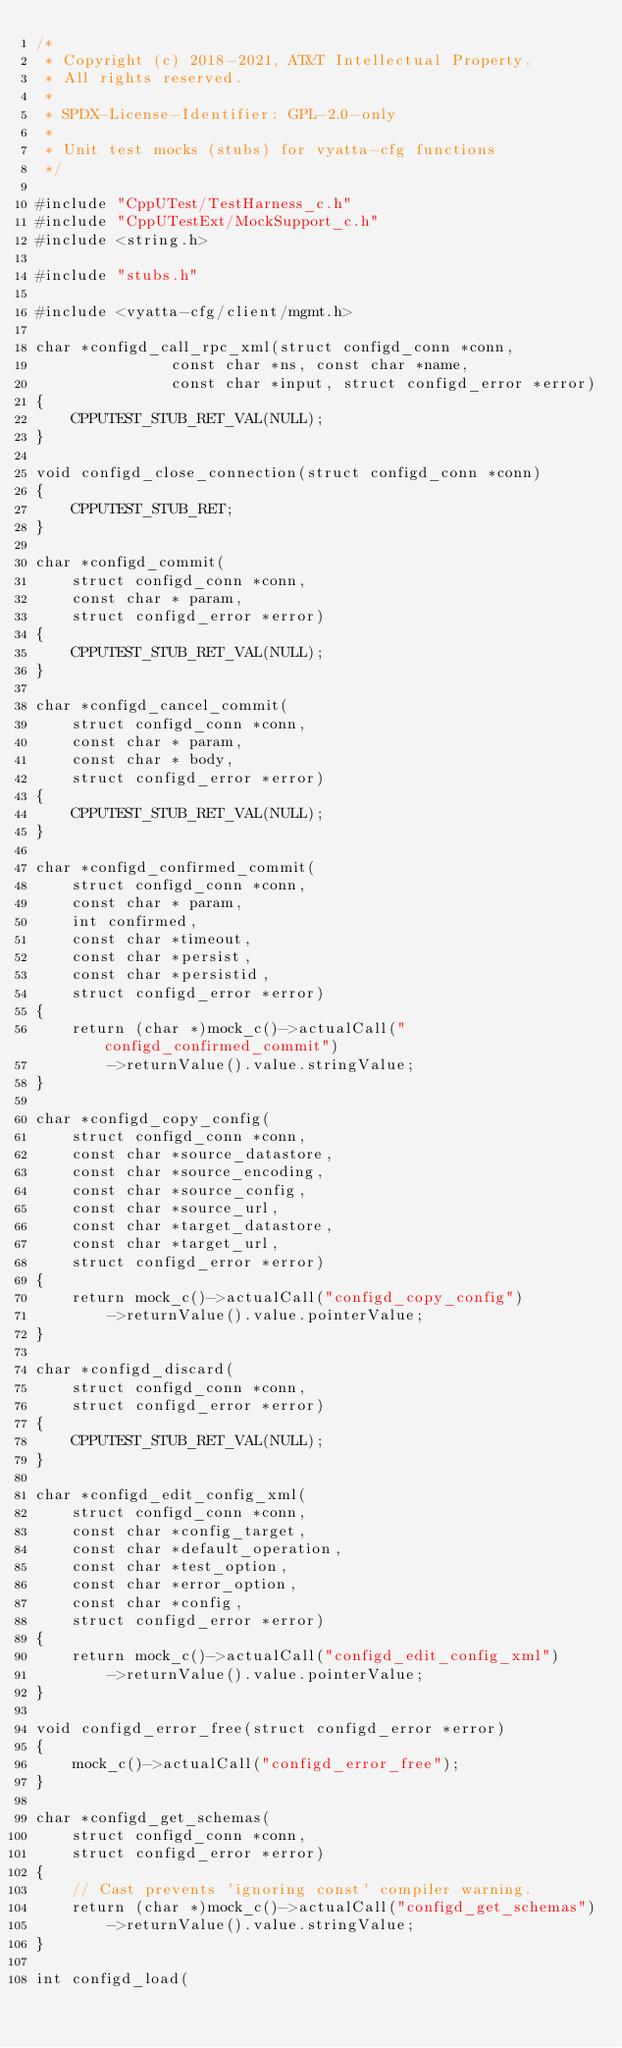Convert code to text. <code><loc_0><loc_0><loc_500><loc_500><_C_>/*
 * Copyright (c) 2018-2021, AT&T Intellectual Property.
 * All rights reserved.
 *
 * SPDX-License-Identifier: GPL-2.0-only
 *
 * Unit test mocks (stubs) for vyatta-cfg functions
 */

#include "CppUTest/TestHarness_c.h"
#include "CppUTestExt/MockSupport_c.h"
#include <string.h>

#include "stubs.h"

#include <vyatta-cfg/client/mgmt.h>

char *configd_call_rpc_xml(struct configd_conn *conn,
			   const char *ns, const char *name,
			   const char *input, struct configd_error *error)
{
	CPPUTEST_STUB_RET_VAL(NULL);
}

void configd_close_connection(struct configd_conn *conn)
{
	CPPUTEST_STUB_RET;
}

char *configd_commit(
	struct configd_conn *conn,
	const char * param,
	struct configd_error *error)
{
	CPPUTEST_STUB_RET_VAL(NULL);
}

char *configd_cancel_commit(
	struct configd_conn *conn,
	const char * param,
	const char * body,
	struct configd_error *error)
{
	CPPUTEST_STUB_RET_VAL(NULL);
}

char *configd_confirmed_commit(
	struct configd_conn *conn,
	const char * param,
	int confirmed,
	const char *timeout,
	const char *persist,
	const char *persistid,
	struct configd_error *error)
{
	return (char *)mock_c()->actualCall("configd_confirmed_commit")
		->returnValue().value.stringValue;
}

char *configd_copy_config(
	struct configd_conn *conn,
	const char *source_datastore,
	const char *source_encoding,
	const char *source_config,
	const char *source_url,
	const char *target_datastore,
	const char *target_url,
	struct configd_error *error)
{
	return mock_c()->actualCall("configd_copy_config")
		->returnValue().value.pointerValue;
}

char *configd_discard(
	struct configd_conn *conn,
	struct configd_error *error)
{
	CPPUTEST_STUB_RET_VAL(NULL);
}

char *configd_edit_config_xml(
	struct configd_conn *conn,
	const char *config_target,
	const char *default_operation,
	const char *test_option,
	const char *error_option,
	const char *config,
	struct configd_error *error)
{
	return mock_c()->actualCall("configd_edit_config_xml")
		->returnValue().value.pointerValue;
}

void configd_error_free(struct configd_error *error)
{
	mock_c()->actualCall("configd_error_free");
}

char *configd_get_schemas(
	struct configd_conn *conn,
	struct configd_error *error)
{
	// Cast prevents 'ignoring const' compiler warning.
	return (char *)mock_c()->actualCall("configd_get_schemas")
		->returnValue().value.stringValue;
}

int configd_load(</code> 